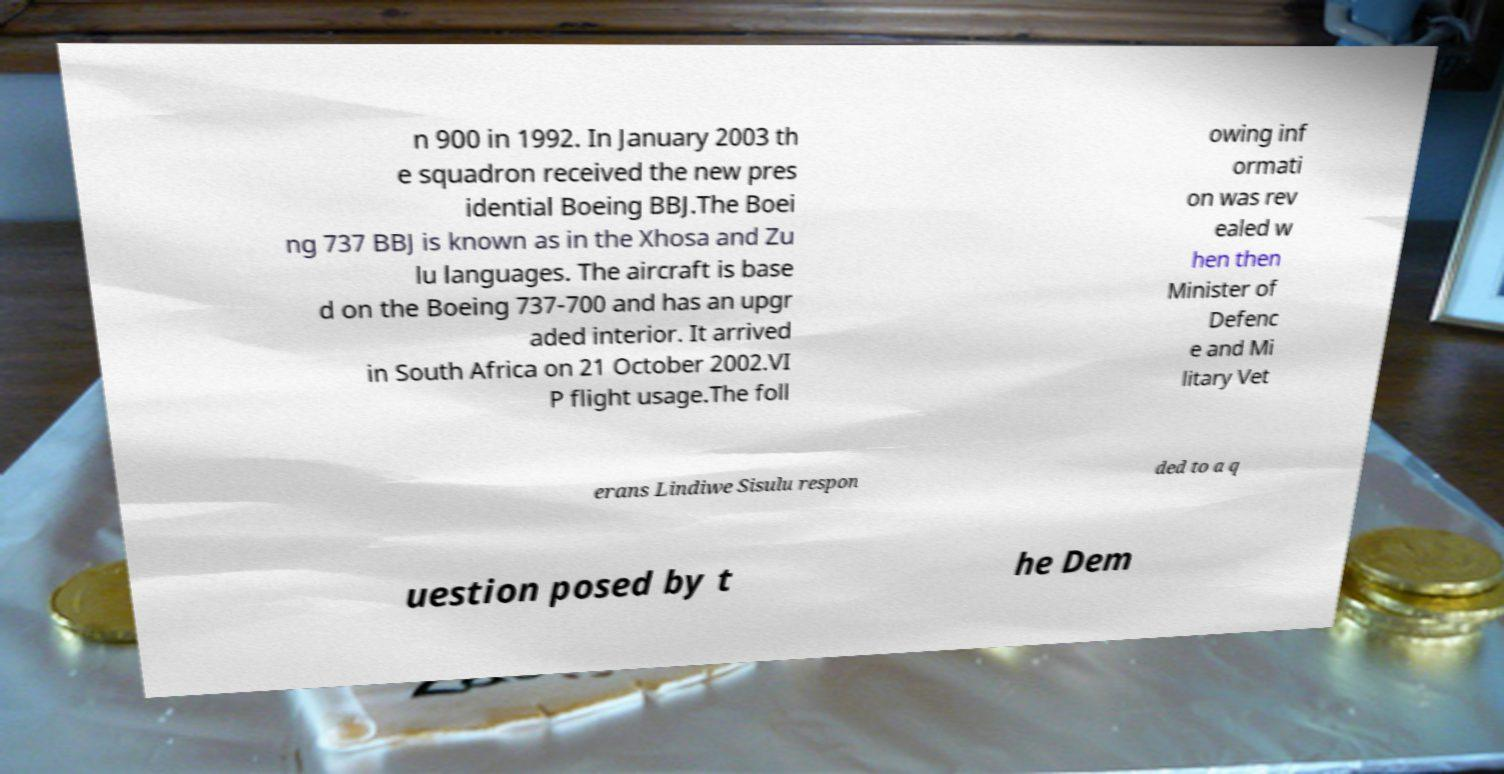Please read and relay the text visible in this image. What does it say? n 900 in 1992. In January 2003 th e squadron received the new pres idential Boeing BBJ.The Boei ng 737 BBJ is known as in the Xhosa and Zu lu languages. The aircraft is base d on the Boeing 737-700 and has an upgr aded interior. It arrived in South Africa on 21 October 2002.VI P flight usage.The foll owing inf ormati on was rev ealed w hen then Minister of Defenc e and Mi litary Vet erans Lindiwe Sisulu respon ded to a q uestion posed by t he Dem 